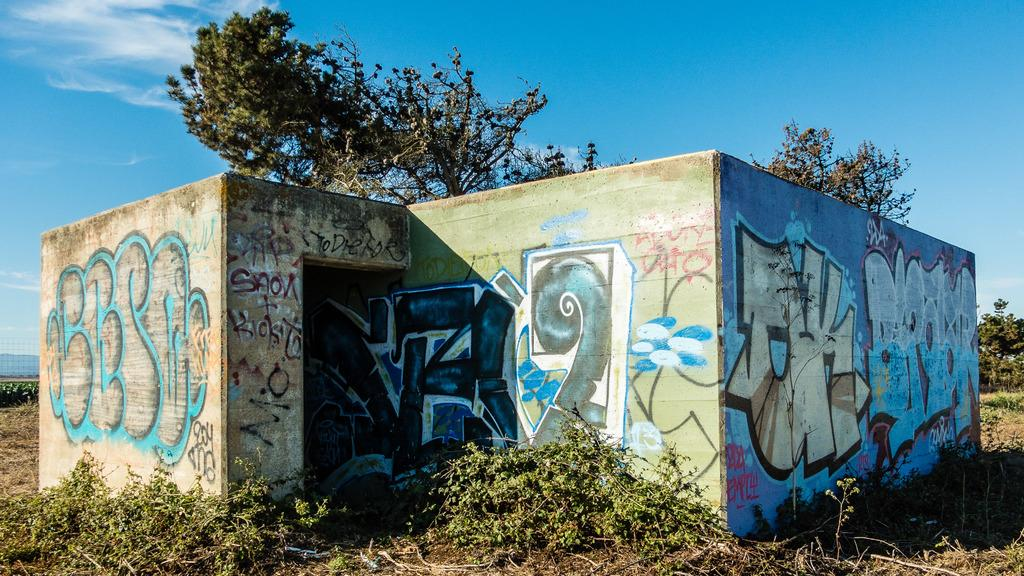What is on the walls of the building in the image? There is graffiti on the walls of a building in the image. What type of vegetation can be seen in the image? There is grass and trees visible in the image. What is visible in the background of the image? The sky is visible in the background of the image. What can be observed in the sky? Clouds are present in the sky. Can you see a boy waving good-bye in the image? There is no boy present in the image, nor is anyone waving good-bye. 